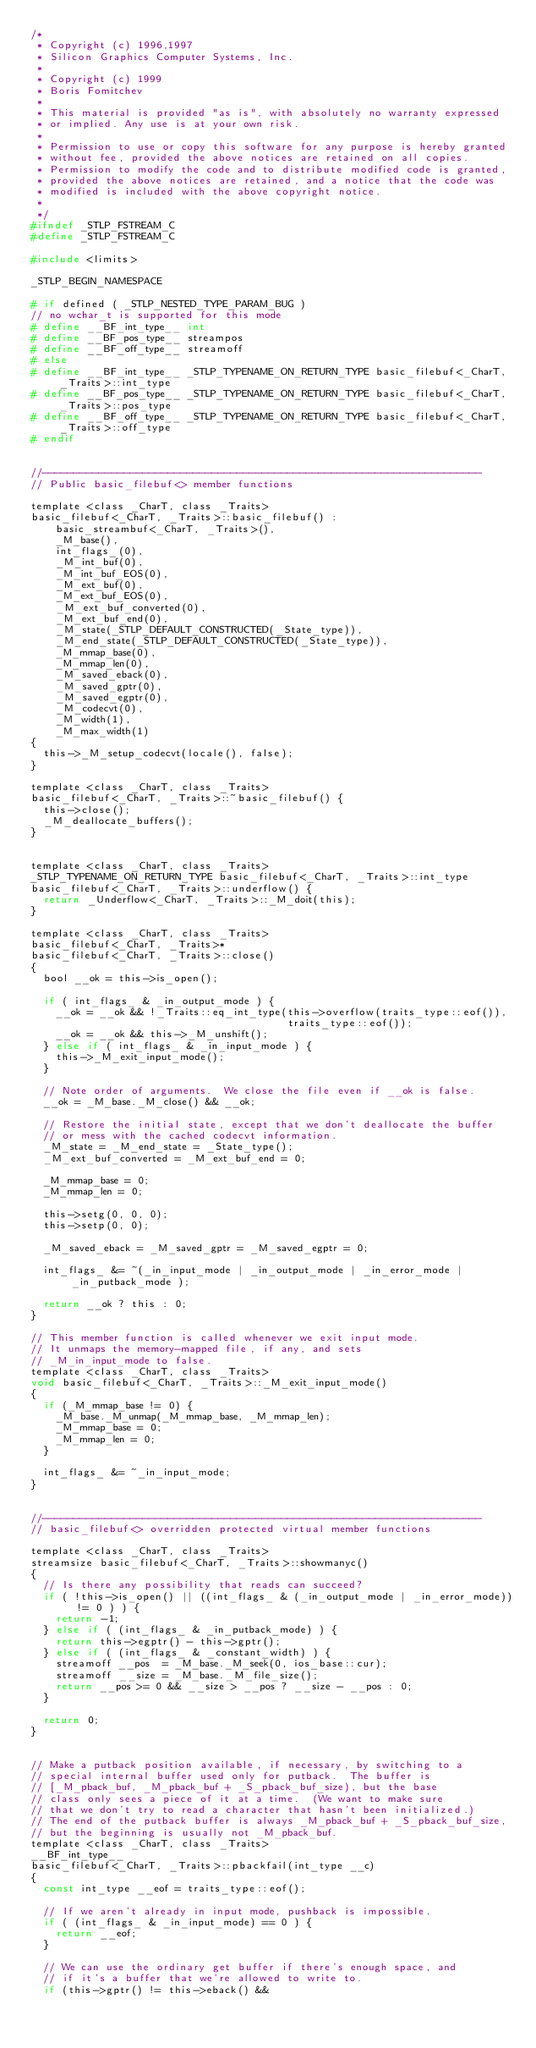Convert code to text. <code><loc_0><loc_0><loc_500><loc_500><_C_>/*
 * Copyright (c) 1996,1997
 * Silicon Graphics Computer Systems, Inc.
 *
 * Copyright (c) 1999
 * Boris Fomitchev
 *
 * This material is provided "as is", with absolutely no warranty expressed
 * or implied. Any use is at your own risk.
 *
 * Permission to use or copy this software for any purpose is hereby granted
 * without fee, provided the above notices are retained on all copies.
 * Permission to modify the code and to distribute modified code is granted,
 * provided the above notices are retained, and a notice that the code was
 * modified is included with the above copyright notice.
 *
 */
#ifndef _STLP_FSTREAM_C
#define _STLP_FSTREAM_C

#include <limits>

_STLP_BEGIN_NAMESPACE

# if defined ( _STLP_NESTED_TYPE_PARAM_BUG )
// no wchar_t is supported for this mode
# define __BF_int_type__ int
# define __BF_pos_type__ streampos
# define __BF_off_type__ streamoff
# else
# define __BF_int_type__ _STLP_TYPENAME_ON_RETURN_TYPE basic_filebuf<_CharT, _Traits>::int_type
# define __BF_pos_type__ _STLP_TYPENAME_ON_RETURN_TYPE basic_filebuf<_CharT, _Traits>::pos_type
# define __BF_off_type__ _STLP_TYPENAME_ON_RETURN_TYPE basic_filebuf<_CharT, _Traits>::off_type
# endif


//----------------------------------------------------------------------
// Public basic_filebuf<> member functions

template <class _CharT, class _Traits>
basic_filebuf<_CharT, _Traits>::basic_filebuf() :
    basic_streambuf<_CharT, _Traits>(),
    _M_base(),
    int_flags_(0),
    _M_int_buf(0),
    _M_int_buf_EOS(0),
    _M_ext_buf(0),
    _M_ext_buf_EOS(0),
    _M_ext_buf_converted(0),
    _M_ext_buf_end(0),
    _M_state(_STLP_DEFAULT_CONSTRUCTED(_State_type)),
    _M_end_state(_STLP_DEFAULT_CONSTRUCTED(_State_type)),
    _M_mmap_base(0),
    _M_mmap_len(0),
    _M_saved_eback(0),
    _M_saved_gptr(0),
    _M_saved_egptr(0),
    _M_codecvt(0),
    _M_width(1),
    _M_max_width(1)
{
  this->_M_setup_codecvt(locale(), false);
}

template <class _CharT, class _Traits>
basic_filebuf<_CharT, _Traits>::~basic_filebuf() {
  this->close();
  _M_deallocate_buffers();
}


template <class _CharT, class _Traits>
_STLP_TYPENAME_ON_RETURN_TYPE basic_filebuf<_CharT, _Traits>::int_type
basic_filebuf<_CharT, _Traits>::underflow() {
  return _Underflow<_CharT, _Traits>::_M_doit(this);
}

template <class _CharT, class _Traits>
basic_filebuf<_CharT, _Traits>*
basic_filebuf<_CharT, _Traits>::close()
{
  bool __ok = this->is_open();

  if ( int_flags_ & _in_output_mode ) {
    __ok = __ok && !_Traits::eq_int_type(this->overflow(traits_type::eof()),
                                         traits_type::eof());
    __ok = __ok && this->_M_unshift();
  } else if ( int_flags_ & _in_input_mode ) {
    this->_M_exit_input_mode();
  }

  // Note order of arguments.  We close the file even if __ok is false.
  __ok = _M_base._M_close() && __ok;

  // Restore the initial state, except that we don't deallocate the buffer
  // or mess with the cached codecvt information.
  _M_state = _M_end_state = _State_type();
  _M_ext_buf_converted = _M_ext_buf_end = 0;

  _M_mmap_base = 0;
  _M_mmap_len = 0;

  this->setg(0, 0, 0);
  this->setp(0, 0);

  _M_saved_eback = _M_saved_gptr = _M_saved_egptr = 0;

  int_flags_ &= ~(_in_input_mode | _in_output_mode | _in_error_mode | _in_putback_mode );

  return __ok ? this : 0;
}

// This member function is called whenever we exit input mode.
// It unmaps the memory-mapped file, if any, and sets
// _M_in_input_mode to false.
template <class _CharT, class _Traits>
void basic_filebuf<_CharT, _Traits>::_M_exit_input_mode()
{
  if (_M_mmap_base != 0) {
    _M_base._M_unmap(_M_mmap_base, _M_mmap_len);
    _M_mmap_base = 0;
    _M_mmap_len = 0;
  }

  int_flags_ &= ~_in_input_mode;
}


//----------------------------------------------------------------------
// basic_filebuf<> overridden protected virtual member functions

template <class _CharT, class _Traits>
streamsize basic_filebuf<_CharT, _Traits>::showmanyc()
{
  // Is there any possibility that reads can succeed?
  if ( !this->is_open() || ((int_flags_ & (_in_output_mode | _in_error_mode)) != 0 ) ) {
    return -1;
  } else if ( (int_flags_ & _in_putback_mode) ) {
    return this->egptr() - this->gptr();
  } else if ( (int_flags_ & _constant_width) ) {
    streamoff __pos  = _M_base._M_seek(0, ios_base::cur);
    streamoff __size = _M_base._M_file_size();
    return __pos >= 0 && __size > __pos ? __size - __pos : 0;
  }

  return 0;
}


// Make a putback position available, if necessary, by switching to a
// special internal buffer used only for putback.  The buffer is
// [_M_pback_buf, _M_pback_buf + _S_pback_buf_size), but the base
// class only sees a piece of it at a time.  (We want to make sure
// that we don't try to read a character that hasn't been initialized.)
// The end of the putback buffer is always _M_pback_buf + _S_pback_buf_size,
// but the beginning is usually not _M_pback_buf.
template <class _CharT, class _Traits>
__BF_int_type__
basic_filebuf<_CharT, _Traits>::pbackfail(int_type __c)
{
  const int_type __eof = traits_type::eof();

  // If we aren't already in input mode, pushback is impossible.
  if ( (int_flags_ & _in_input_mode) == 0 ) {
    return __eof;
  }

  // We can use the ordinary get buffer if there's enough space, and
  // if it's a buffer that we're allowed to write to.
  if (this->gptr() != this->eback() &&</code> 